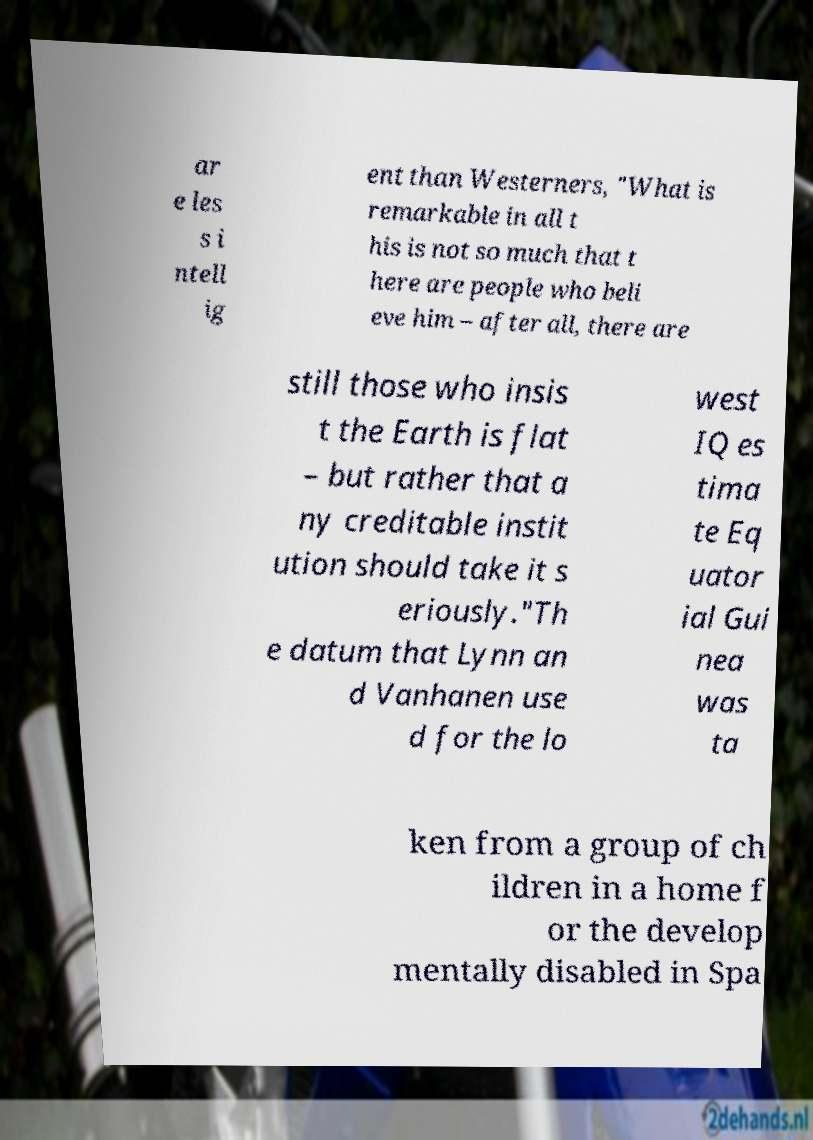For documentation purposes, I need the text within this image transcribed. Could you provide that? ar e les s i ntell ig ent than Westerners, "What is remarkable in all t his is not so much that t here are people who beli eve him – after all, there are still those who insis t the Earth is flat – but rather that a ny creditable instit ution should take it s eriously."Th e datum that Lynn an d Vanhanen use d for the lo west IQ es tima te Eq uator ial Gui nea was ta ken from a group of ch ildren in a home f or the develop mentally disabled in Spa 